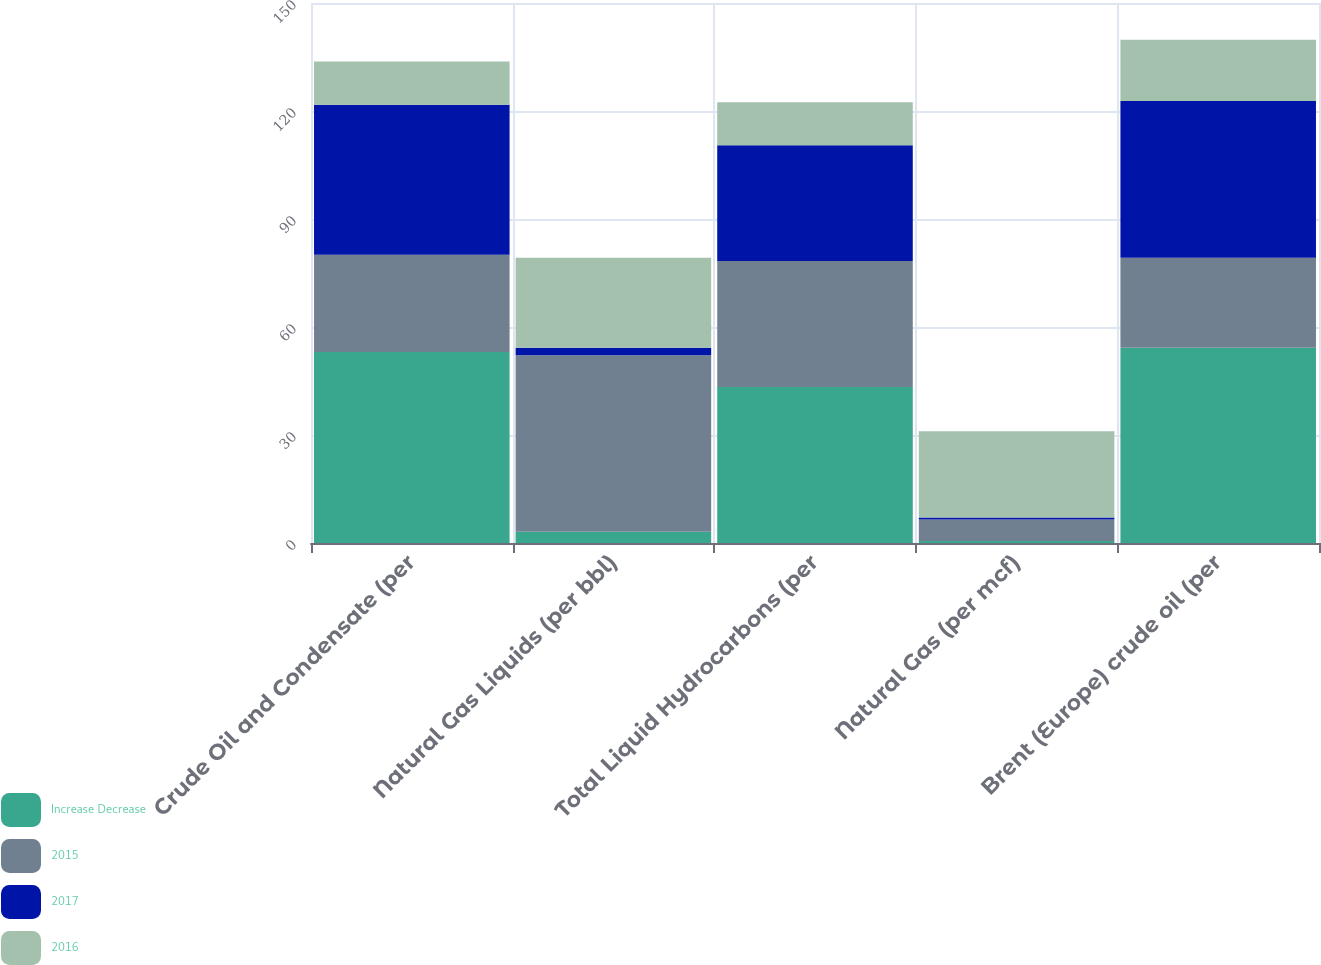Convert chart. <chart><loc_0><loc_0><loc_500><loc_500><stacked_bar_chart><ecel><fcel>Crude Oil and Condensate (per<fcel>Natural Gas Liquids (per bbl)<fcel>Total Liquid Hydrocarbons (per<fcel>Natural Gas (per mcf)<fcel>Brent (Europe) crude oil (per<nl><fcel>Increase Decrease<fcel>53.05<fcel>3.15<fcel>43.36<fcel>0.55<fcel>54.25<nl><fcel>2015<fcel>27<fcel>49<fcel>35<fcel>6<fcel>25<nl><fcel>2017<fcel>41.7<fcel>2.11<fcel>32.1<fcel>0.52<fcel>43.55<nl><fcel>2016<fcel>12<fcel>25<fcel>12<fcel>24<fcel>17<nl></chart> 